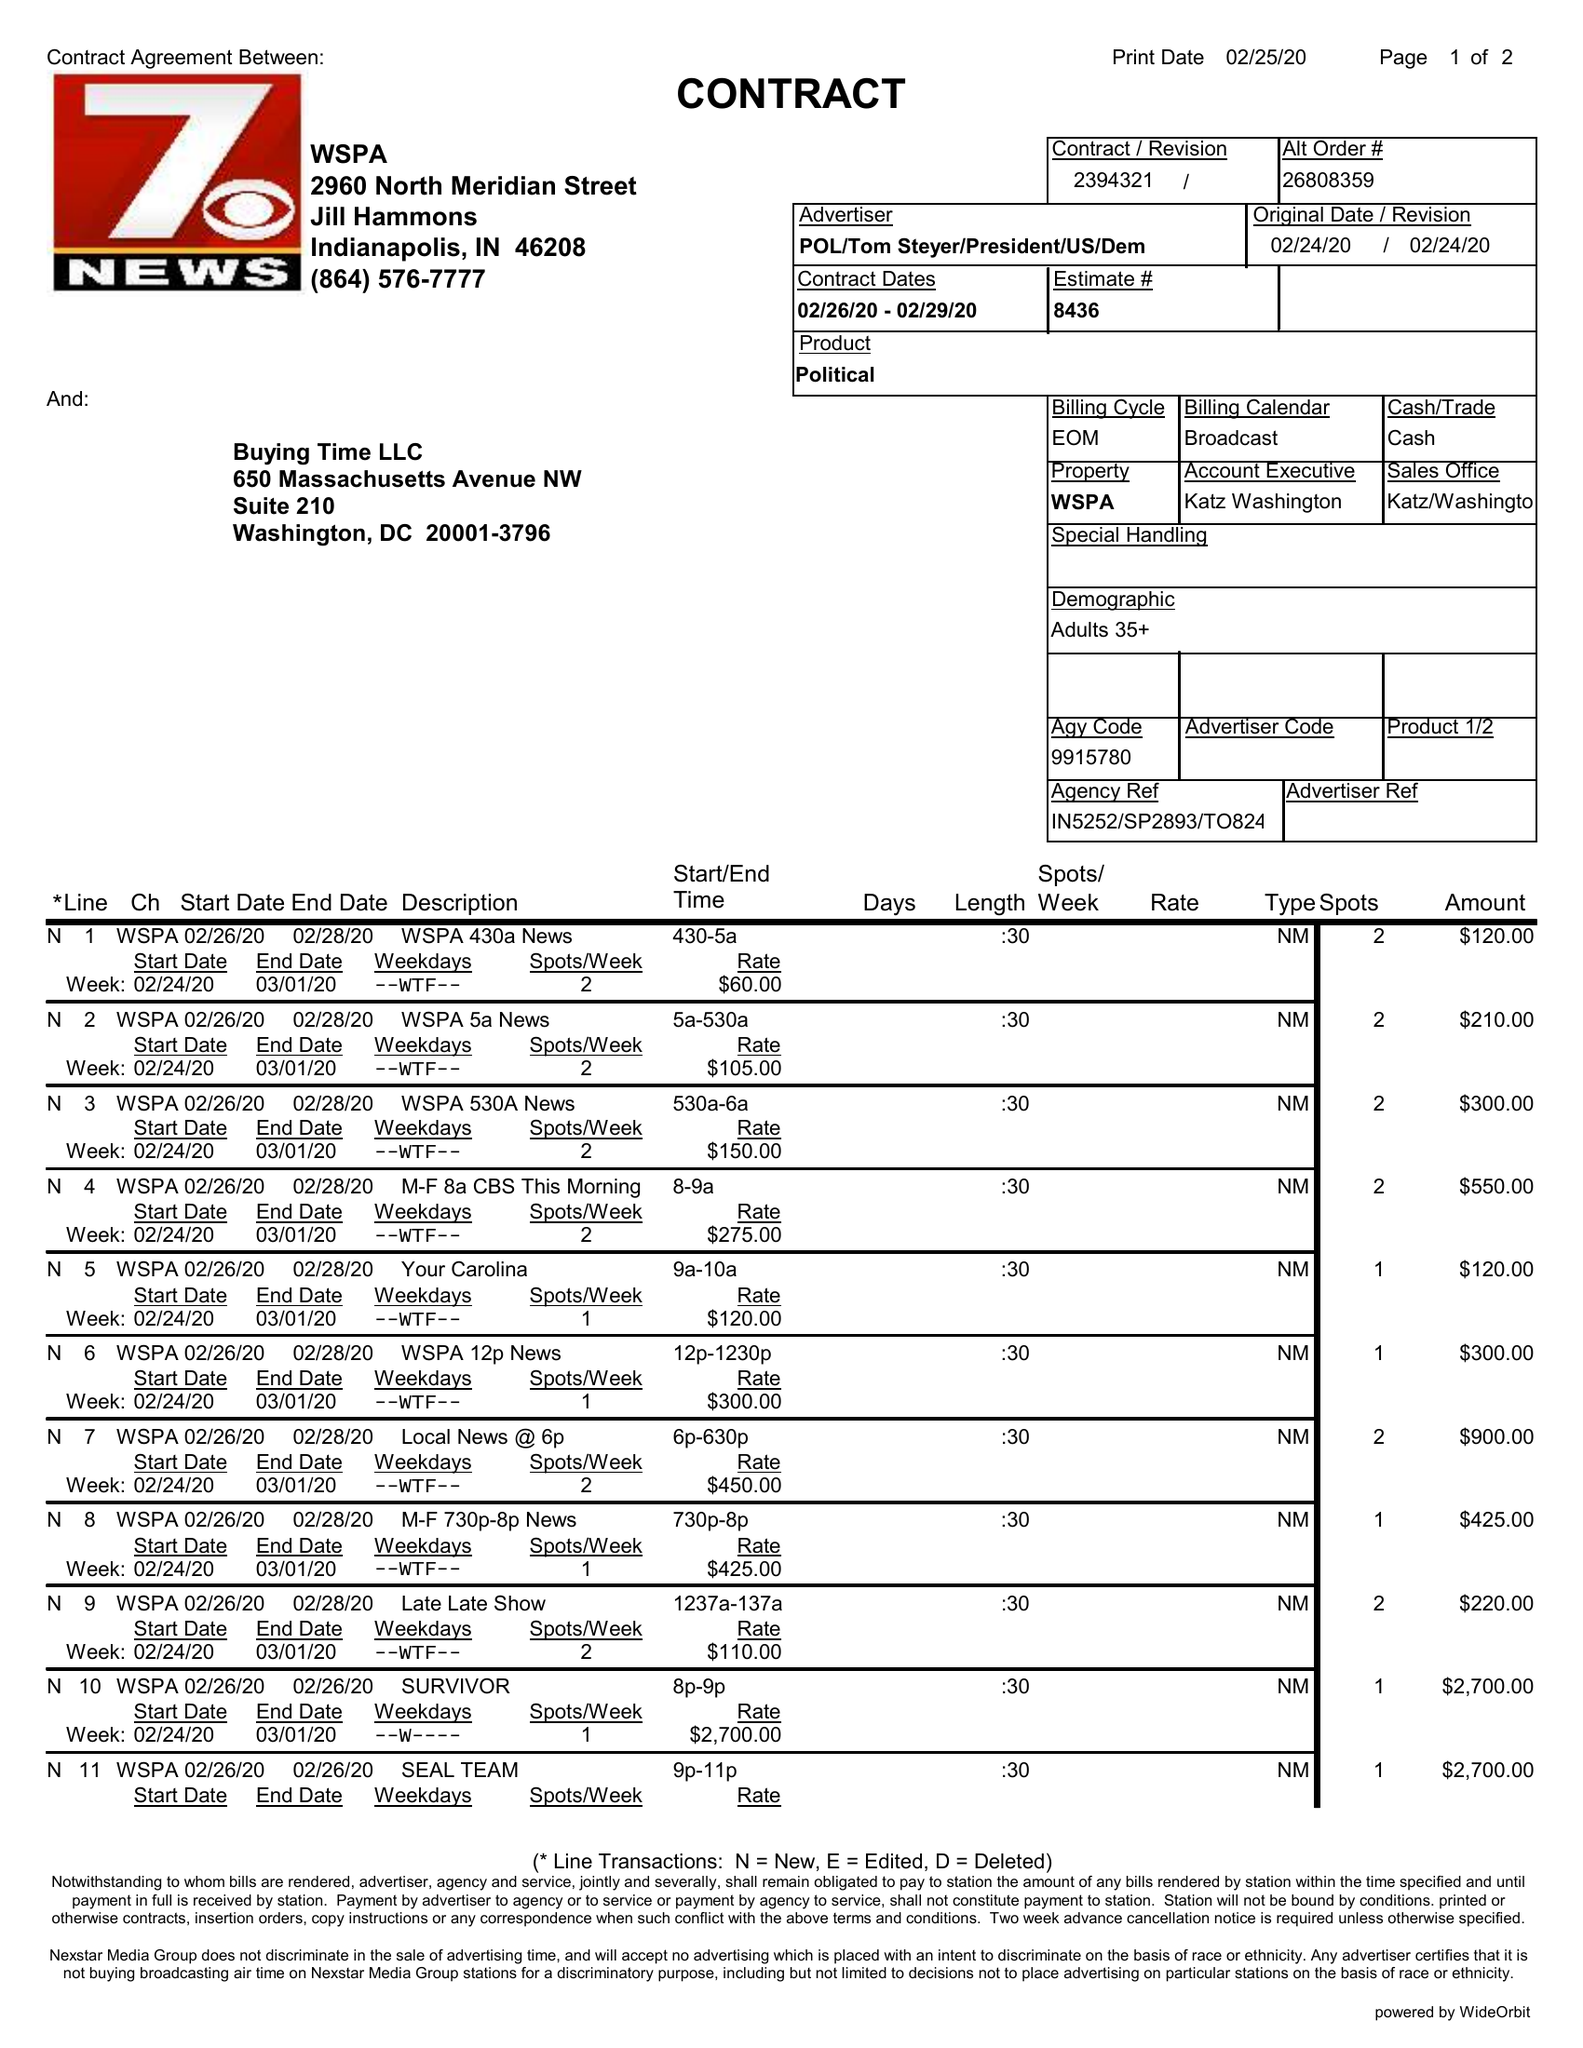What is the value for the contract_num?
Answer the question using a single word or phrase. 2394321 